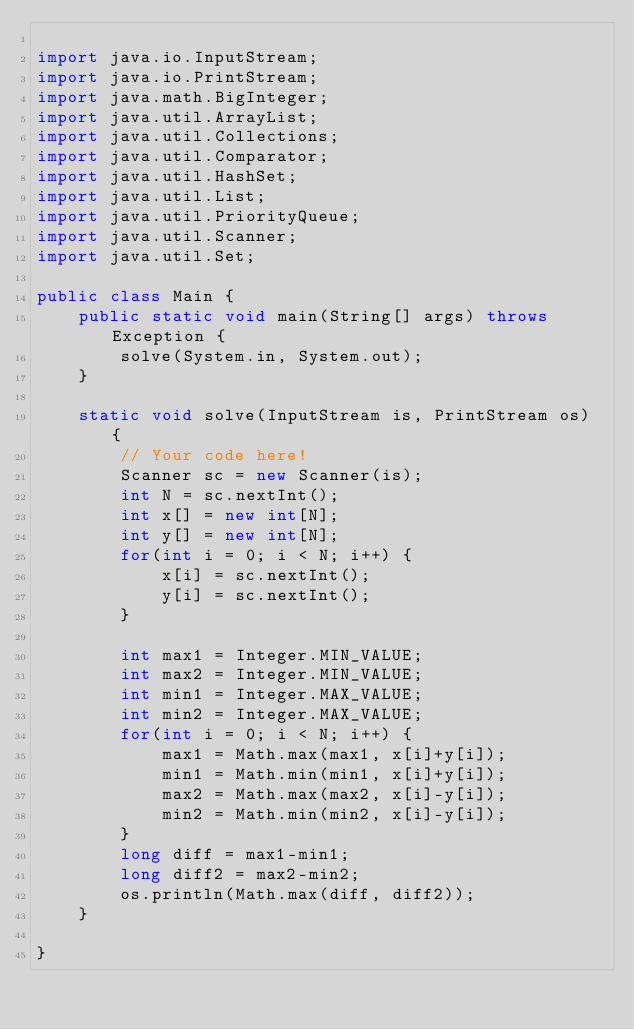Convert code to text. <code><loc_0><loc_0><loc_500><loc_500><_Java_>
import java.io.InputStream;
import java.io.PrintStream;
import java.math.BigInteger;
import java.util.ArrayList;
import java.util.Collections;
import java.util.Comparator;
import java.util.HashSet;
import java.util.List;
import java.util.PriorityQueue;
import java.util.Scanner;
import java.util.Set;

public class Main {
    public static void main(String[] args) throws Exception {
        solve(System.in, System.out);
    }

    static void solve(InputStream is, PrintStream os) {
        // Your code here!
        Scanner sc = new Scanner(is);
        int N = sc.nextInt();
        int x[] = new int[N];
        int y[] = new int[N];
        for(int i = 0; i < N; i++) {
            x[i] = sc.nextInt();
            y[i] = sc.nextInt();
        }

        int max1 = Integer.MIN_VALUE;
        int max2 = Integer.MIN_VALUE;
        int min1 = Integer.MAX_VALUE;
        int min2 = Integer.MAX_VALUE;
        for(int i = 0; i < N; i++) {
            max1 = Math.max(max1, x[i]+y[i]);
            min1 = Math.min(min1, x[i]+y[i]);
            max2 = Math.max(max2, x[i]-y[i]);
            min2 = Math.min(min2, x[i]-y[i]);
        }
        long diff = max1-min1;
        long diff2 = max2-min2;
        os.println(Math.max(diff, diff2));
    }

}</code> 